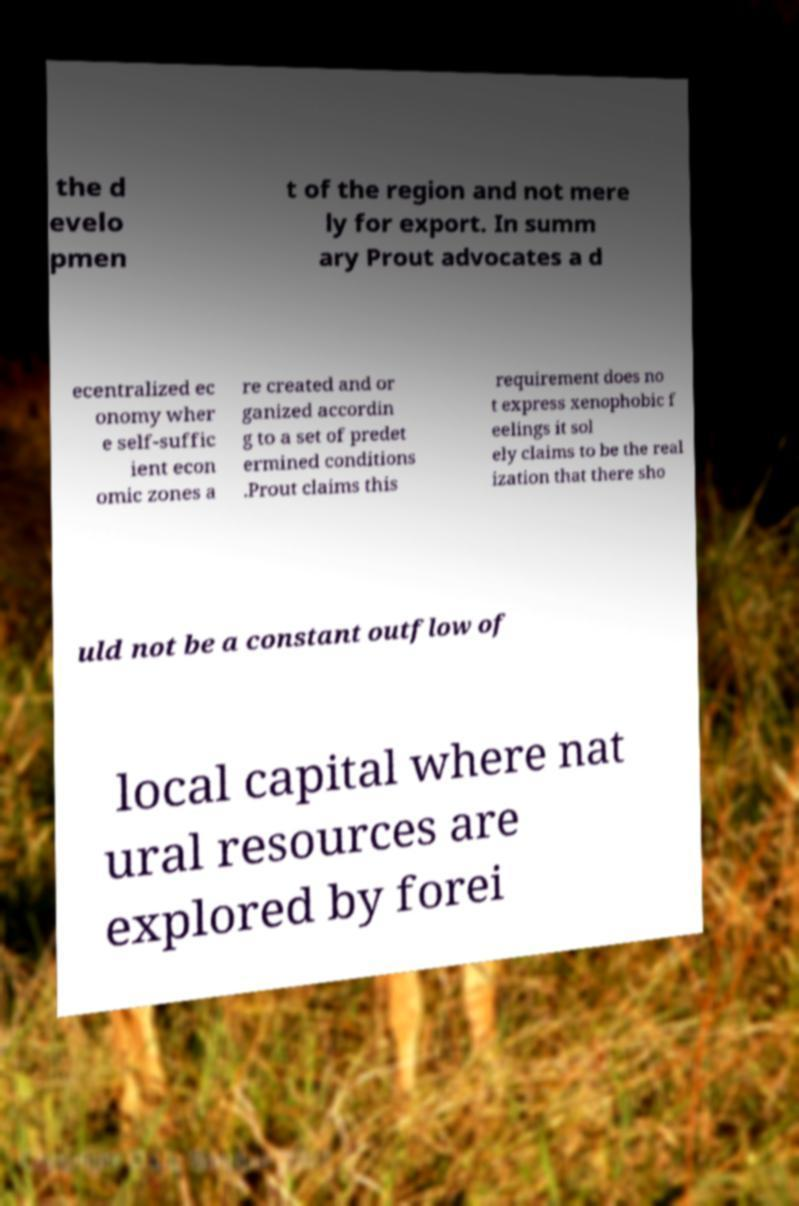What messages or text are displayed in this image? I need them in a readable, typed format. the d evelo pmen t of the region and not mere ly for export. In summ ary Prout advocates a d ecentralized ec onomy wher e self-suffic ient econ omic zones a re created and or ganized accordin g to a set of predet ermined conditions .Prout claims this requirement does no t express xenophobic f eelings it sol ely claims to be the real ization that there sho uld not be a constant outflow of local capital where nat ural resources are explored by forei 